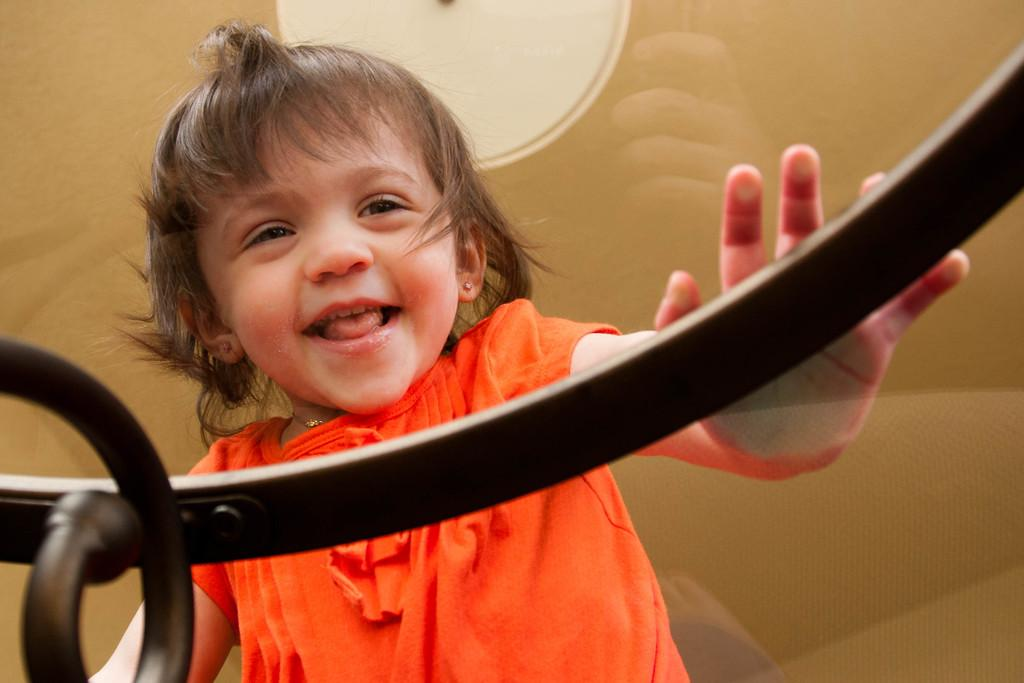Who is the main subject in the image? There is a girl in the image. What is the girl wearing? The girl is wearing an orange dress. What is the girl doing in the image? The girl is touching a glass table. What is on top of the table? There is a light on top of the table. How many sheep can be seen in the image? There are no sheep present in the image. What type of error is the girl correcting in the image? There is no indication of an error or any corrective action in the image. 